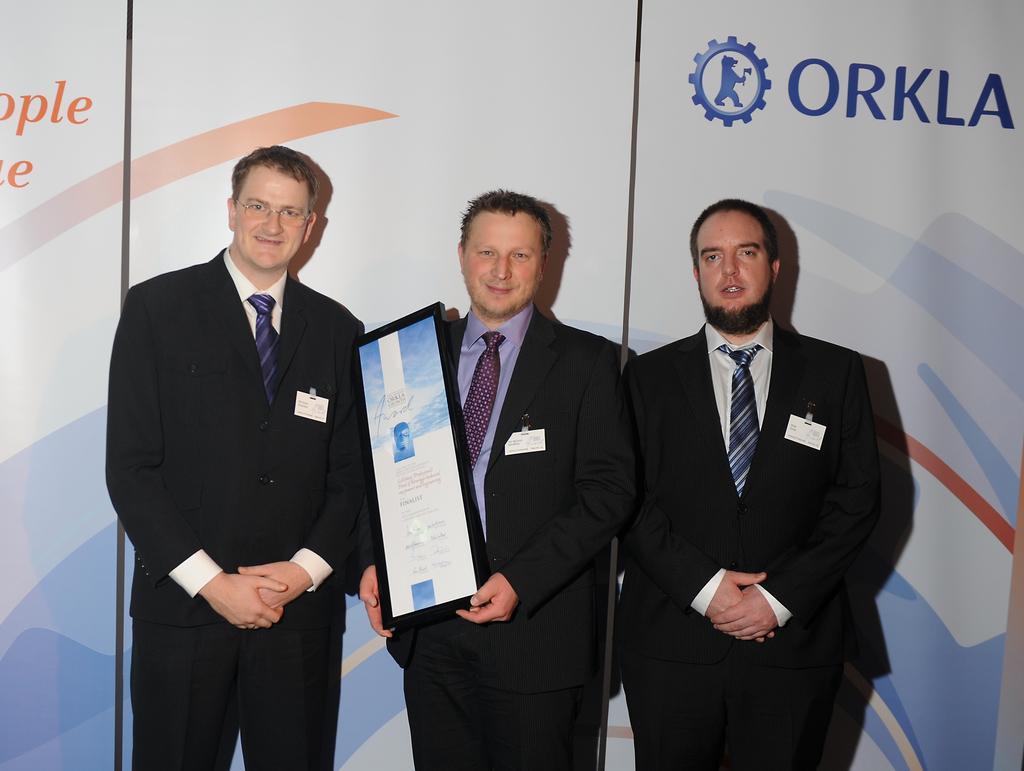In one or two sentences, can you explain what this image depicts? In this image in the center there are three persons who are standing and one person is holding one board, in the background there are some boards. 